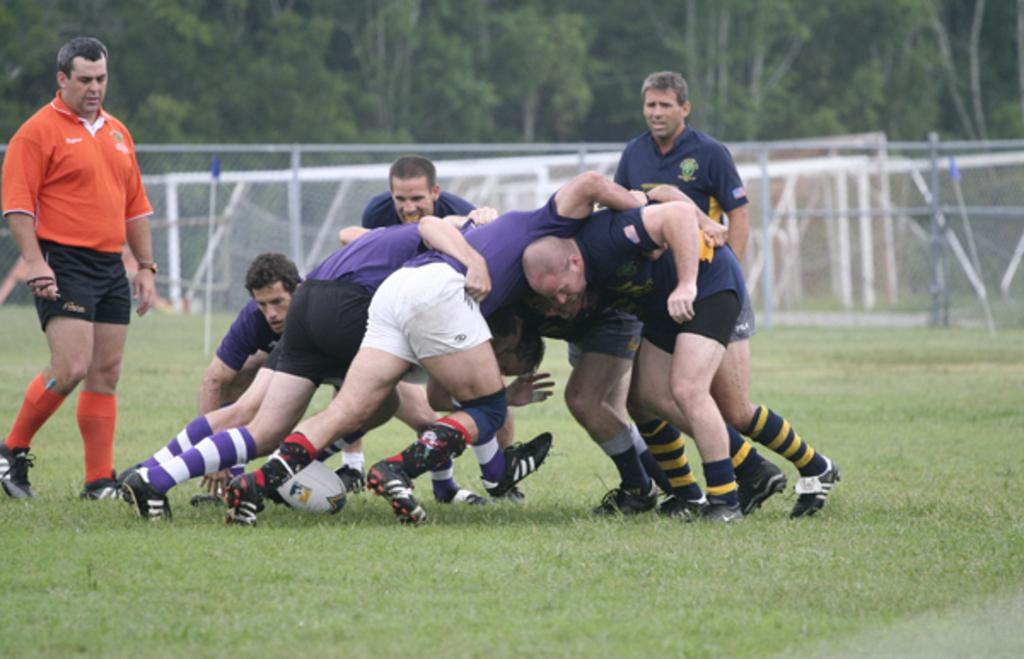What are the people in the image doing? The people in the image are playing. What object is being used by the people playing? A ball is present in the image. What structures are visible in the image? There are poles and a net in the image. What can be seen in the distance in the image? Trees are visible in the background of the image. How does the drain affect the comfort of the people playing in the image? There is no drain present in the image, so it cannot affect the comfort of the people playing. 